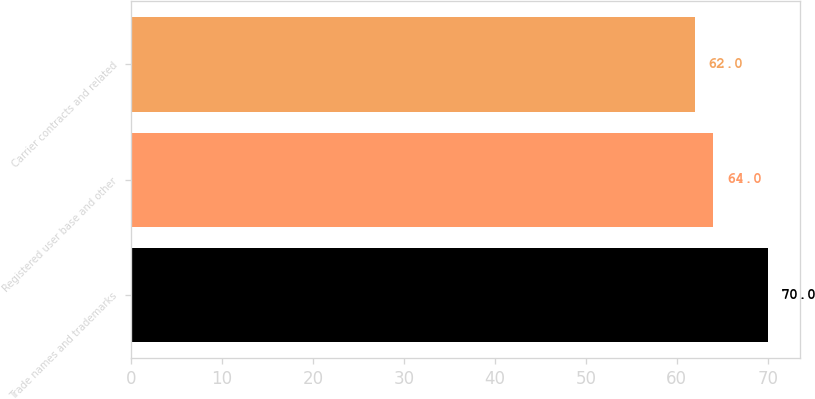<chart> <loc_0><loc_0><loc_500><loc_500><bar_chart><fcel>Trade names and trademarks<fcel>Registered user base and other<fcel>Carrier contracts and related<nl><fcel>70<fcel>64<fcel>62<nl></chart> 